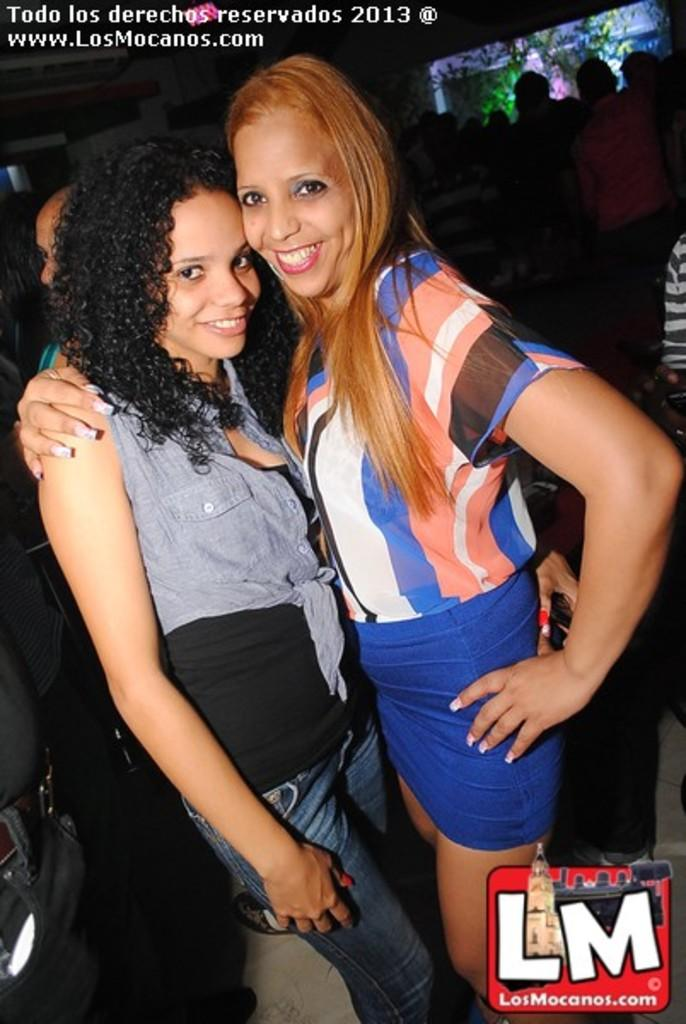How many people are in the image? There is a group of people in the image, but the exact number is not specified. What is the position of the people in the image? The people are standing on the ground in the image. Can you describe any text or writing visible in the image? Yes, there is text or writing visible in the image. How many cherries are being held by the children in the image? There is no mention of children or cherries in the image; it only states that there is a group of people standing on the ground with text or writing visible. 